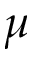Convert formula to latex. <formula><loc_0><loc_0><loc_500><loc_500>\mu</formula> 